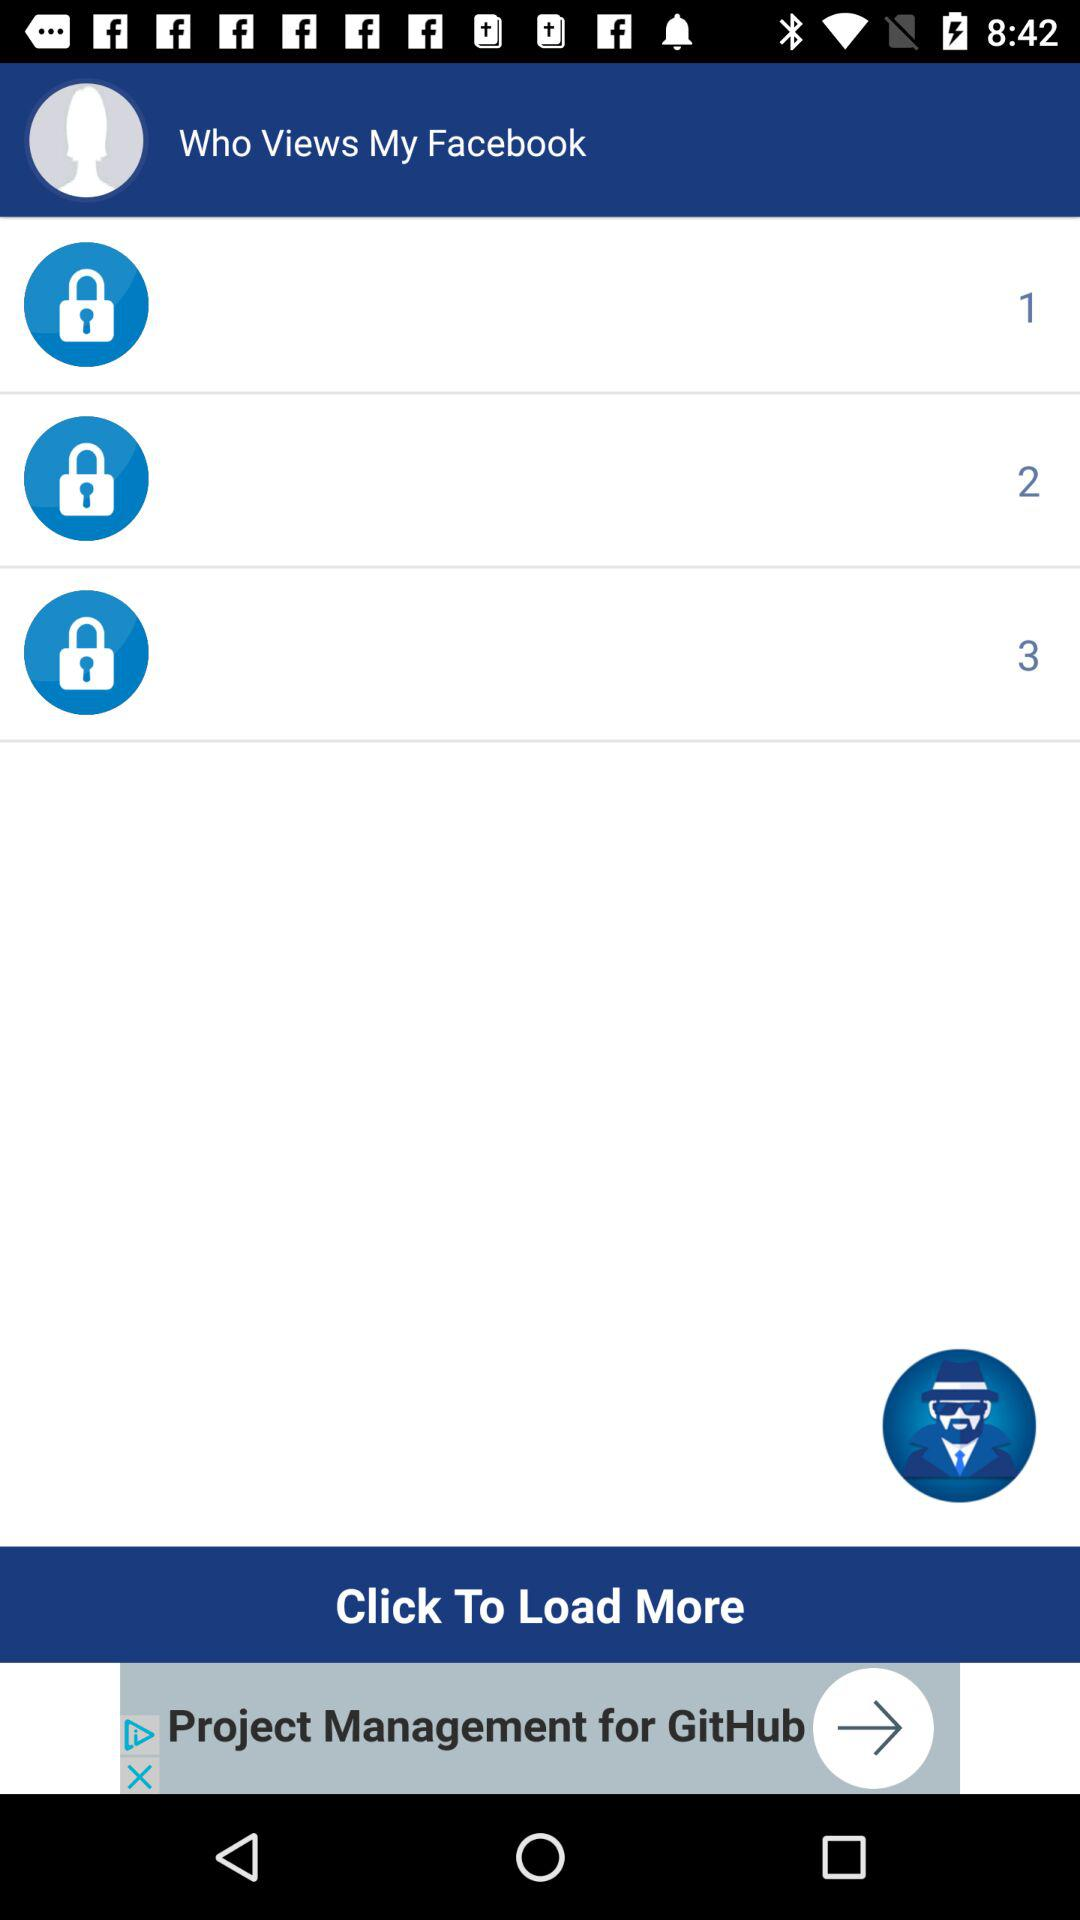How many people have viewed my Facebook profile?
Answer the question using a single word or phrase. 3 